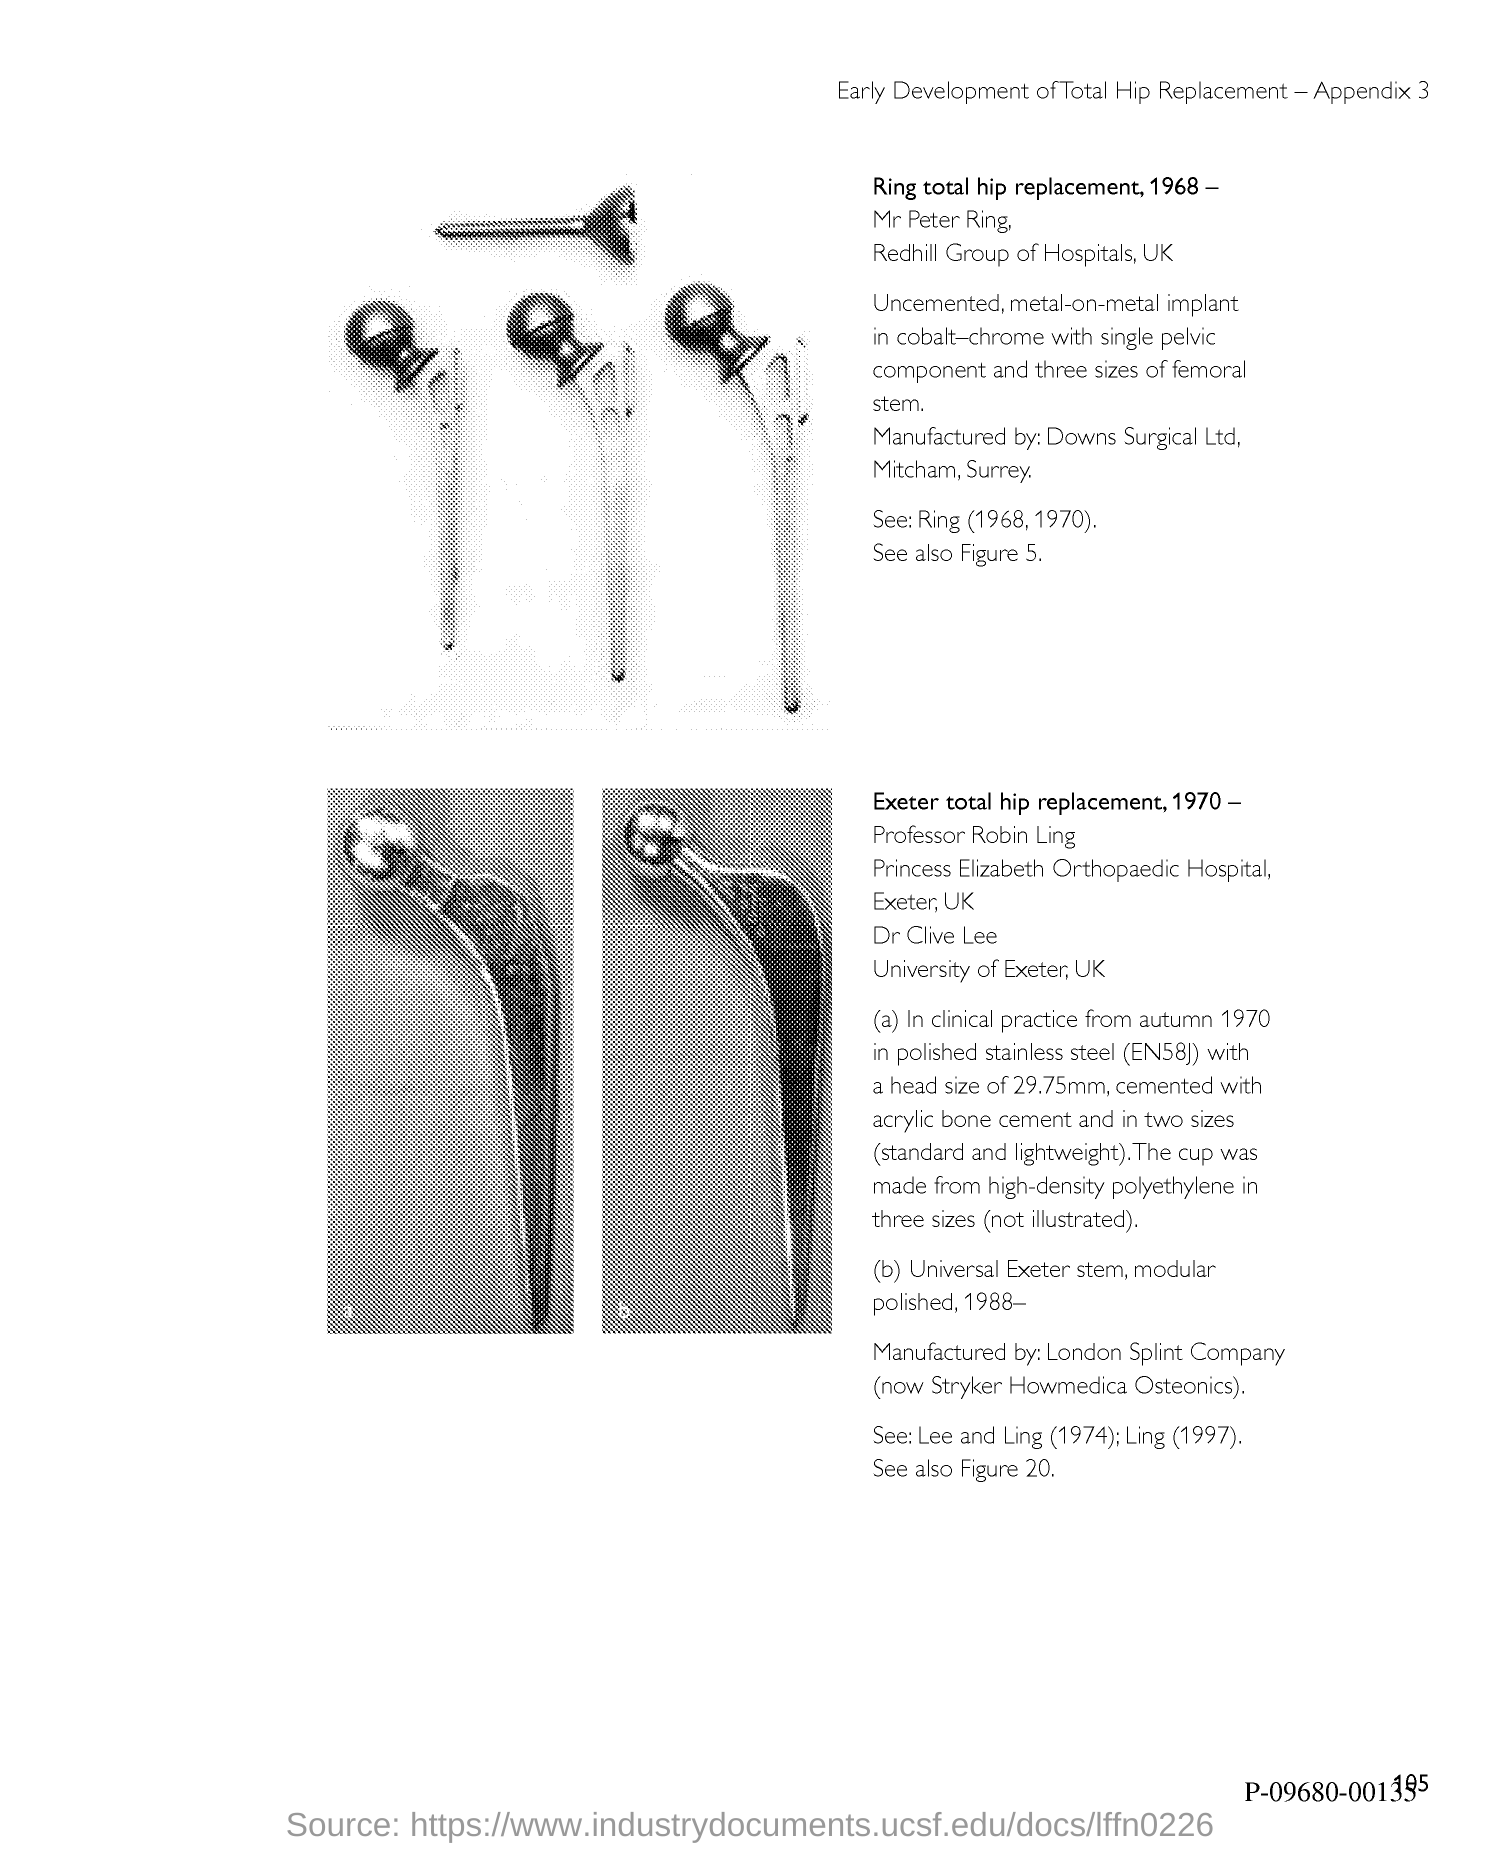What is the Page Number?
Your answer should be compact. 105. 